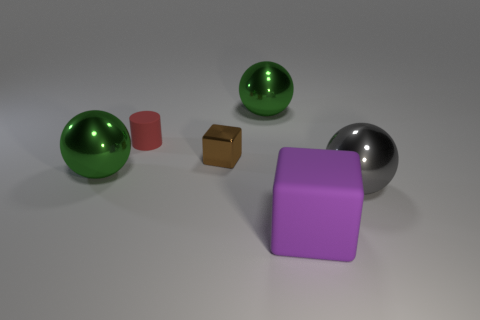Subtract all large gray balls. How many balls are left? 2 Subtract 1 blocks. How many blocks are left? 1 Subtract all brown cubes. How many cubes are left? 1 Add 2 gray shiny cylinders. How many objects exist? 8 Subtract all blocks. How many objects are left? 4 Subtract all small cyan cylinders. Subtract all gray things. How many objects are left? 5 Add 5 shiny cubes. How many shiny cubes are left? 6 Add 5 small cylinders. How many small cylinders exist? 6 Subtract 0 cyan blocks. How many objects are left? 6 Subtract all brown cylinders. Subtract all red spheres. How many cylinders are left? 1 